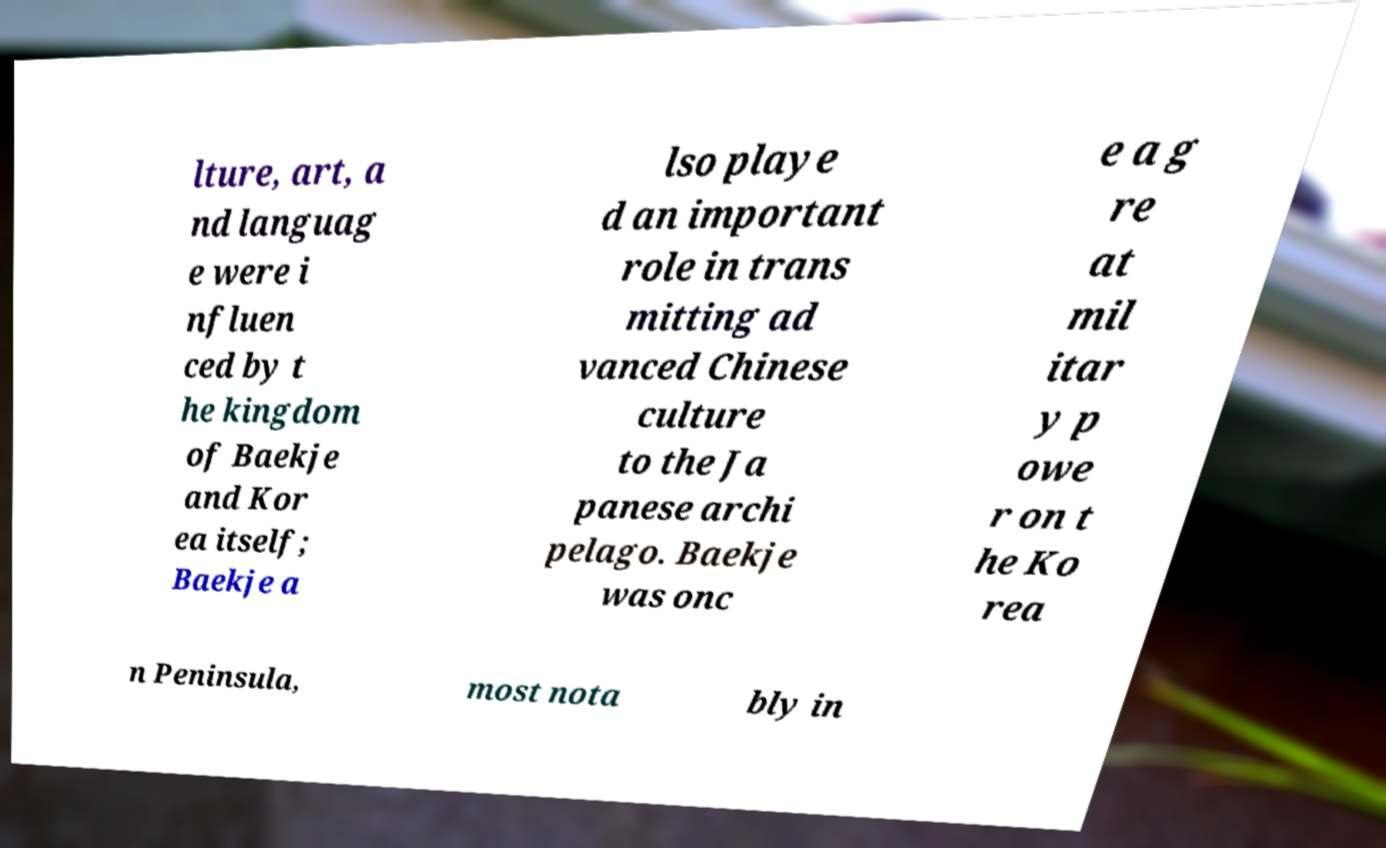Could you assist in decoding the text presented in this image and type it out clearly? lture, art, a nd languag e were i nfluen ced by t he kingdom of Baekje and Kor ea itself; Baekje a lso playe d an important role in trans mitting ad vanced Chinese culture to the Ja panese archi pelago. Baekje was onc e a g re at mil itar y p owe r on t he Ko rea n Peninsula, most nota bly in 